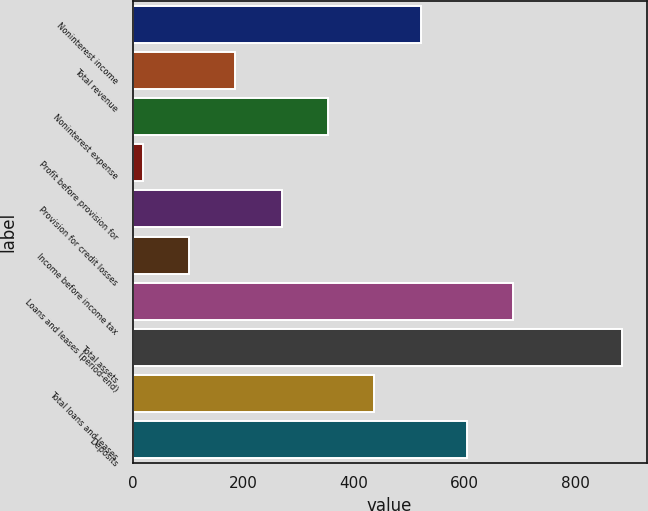Convert chart. <chart><loc_0><loc_0><loc_500><loc_500><bar_chart><fcel>Noninterest income<fcel>Total revenue<fcel>Noninterest expense<fcel>Profit before provision for<fcel>Provision for credit losses<fcel>Income before income tax<fcel>Loans and leases (period-end)<fcel>Total assets<fcel>Total loans and leases<fcel>Deposits<nl><fcel>520.8<fcel>185.6<fcel>353.2<fcel>18<fcel>269.4<fcel>101.8<fcel>688.4<fcel>884.8<fcel>437<fcel>604.6<nl></chart> 